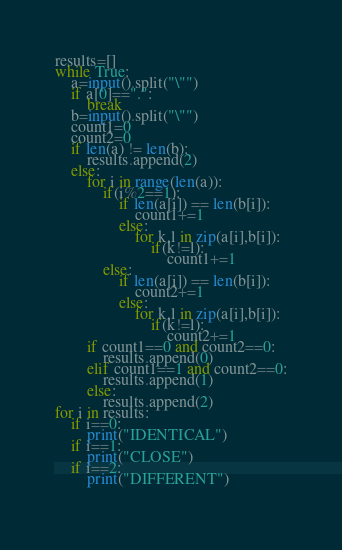<code> <loc_0><loc_0><loc_500><loc_500><_Python_>results=[]
while True:
    a=input().split("\"")
    if a[0]==".":
        break
    b=input().split("\"")
    count1=0
    count2=0
    if len(a) != len(b):
        results.append(2)
    else:
        for i in range(len(a)):
            if(i%2==1):
                if len(a[i]) == len(b[i]):
                    count1+=1
                else:
                    for k,l in zip(a[i],b[i]):
                        if(k!=l):
                            count1+=1
            else:
                if len(a[i]) == len(b[i]):
                    count2+=1
                else:
                    for k,l in zip(a[i],b[i]):
                        if(k!=l):
                            count2+=1           
        if count1==0 and count2==0:
            results.append(0)
        elif count1==1 and count2==0:
            results.append(1)
        else:
            results.append(2)
for i in results:
    if i==0:
        print("IDENTICAL")
    if i==1:
        print("CLOSE")
    if i==2:
        print("DIFFERENT")
    

</code> 